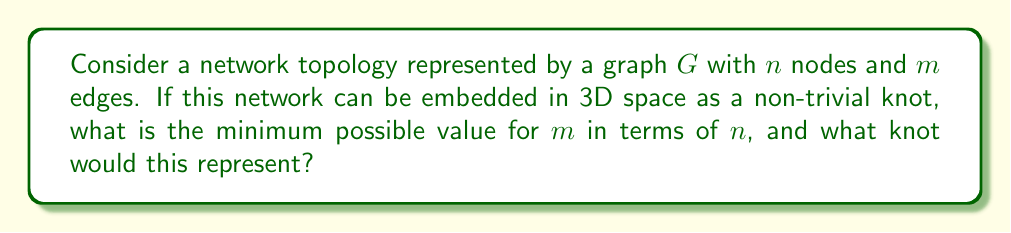Help me with this question. To approach this problem, we'll follow these steps:

1) In knot theory, the simplest non-trivial knot is the trefoil knot. This is what we're aiming for as it requires the least number of crossings (3) to form a knot.

2) In graph theory, to represent a knot, we need a cycle in the graph. The minimum number of edges to form a cycle is equal to the number of nodes.

3) However, to form a non-trivial knot (like the trefoil), we need additional edges to create crossings. Each crossing in a knot diagram corresponds to a node in the graph where four edges meet.

4) The trefoil knot has 3 crossings. In a graph representation, each crossing becomes a node, and we need additional edges to connect these nodes.

5) Therefore, the minimum structure would be:
   - $n$ nodes (where $n \geq 3$)
   - A cycle connecting all $n$ nodes (requiring $n$ edges)
   - 3 additional edges to create the crossings

6) Thus, the minimum number of edges $m$ is:

   $$m = n + 3$$

7) This configuration would represent the trefoil knot, which is the simplest non-trivial knot in knot theory.

Note: In network topology, this kind of analysis can be useful for understanding the complexity and robustness of network structures, especially in 3D network designs or in analyzing the topological properties of molecular structures in computational chemistry.
Answer: $m = n + 3$, representing a trefoil knot 